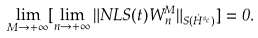Convert formula to latex. <formula><loc_0><loc_0><loc_500><loc_500>\lim _ { M \rightarrow + \infty } [ \lim _ { n \rightarrow + \infty } \| N L S ( t ) W _ { n } ^ { M } \| _ { S ( \dot { H } ^ { s _ { c } } ) } ] = 0 .</formula> 